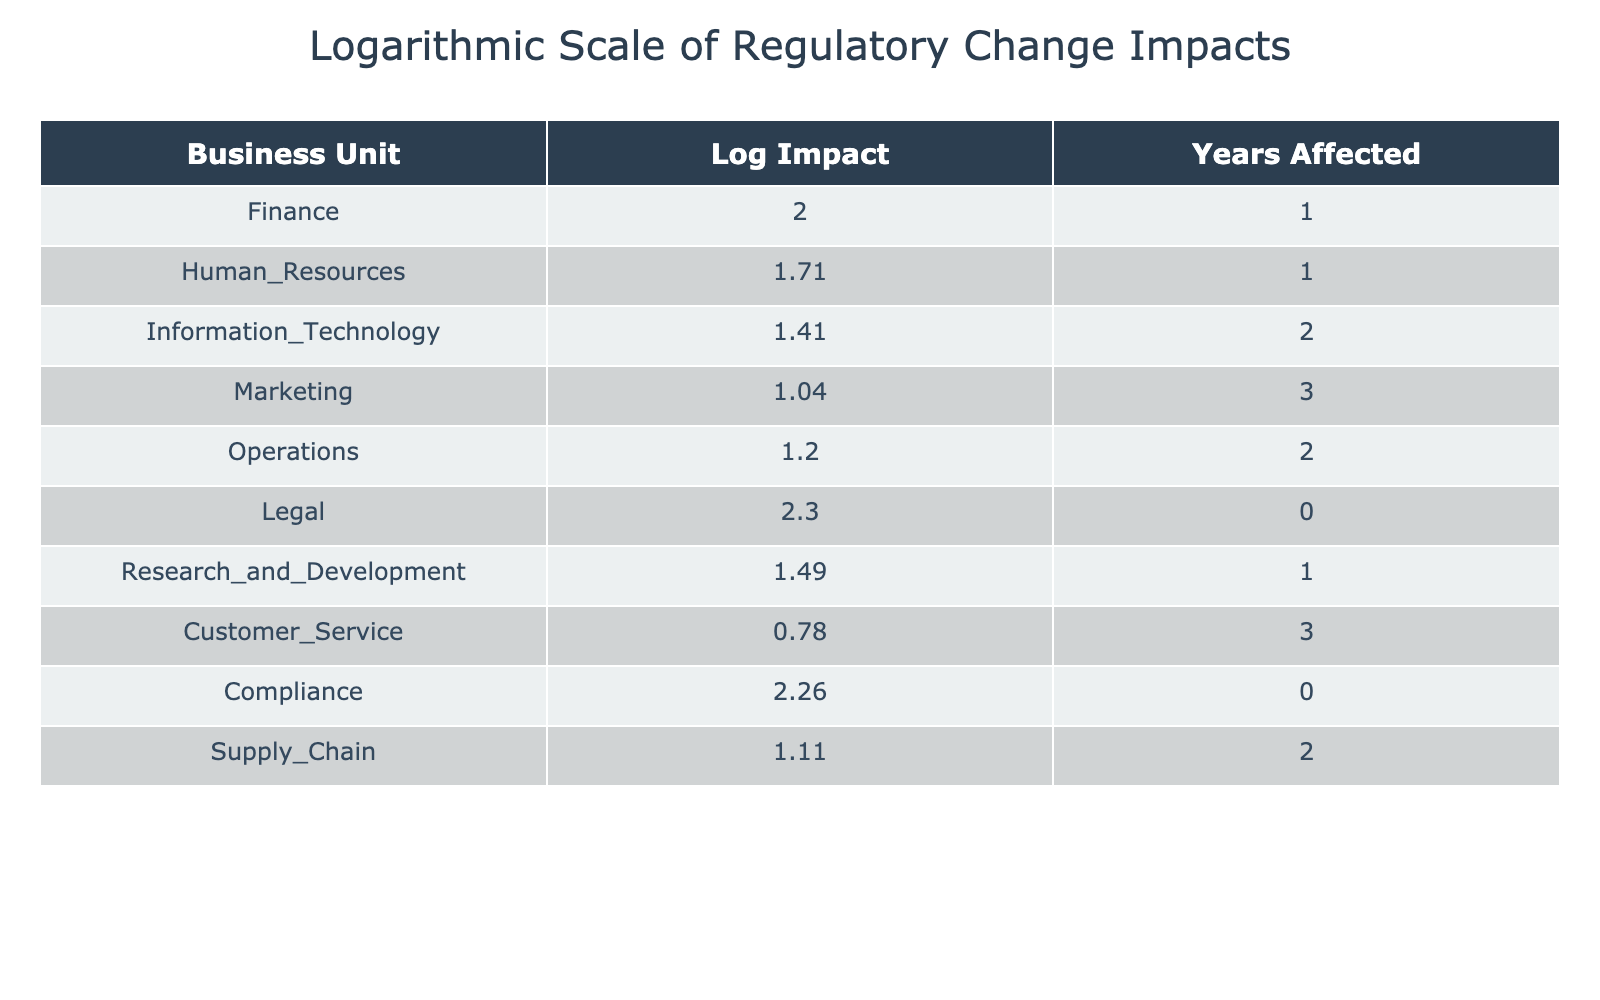What is the Log Impact score for the Finance business unit? The table shows that the Finance business unit has a Regulatory Change Impact Score of 100. The Log Impact for this score can be calculated as log10(100 + 1), which is approximately 2.00. Therefore, the Log Impact score for Finance is 2.00.
Answer: 2.00 Which business unit has the highest Log Impact score? By reviewing the Log Impact scores listed in the table, we observe that the Legal business unit has the highest Regulatory Change Impact Score of 200, which results in a Log Impact score calculated as log10(200 + 1), approximately 2.30. This is higher than any other unit's Log Impact score.
Answer: Legal What is the average Log Impact score of all business units listed? To find the average Log Impact score, we first sum all the individual Log Impact scores from the table and then divide by the number of business units (which is 10). The sum of the Log Impact scores is 2.00 (Finance) + 1.70 (HR) + 1.40 (IT) + 1.00 (Marketing) + 1.10 (Operations) + 2.30 (Legal) + 1.48 (R&D) + 0.70 (Customer Service) + 1.08 (Compliance) + 1.07 (Supply Chain) = 13.65. Dividing that by 10 gives an average of approximately 1.37.
Answer: 1.37 Is there any business unit with a Log Impact score less than 1? Checking the Log Impact scores in the table, we see that Customer Service has a Log Impact score of approximately 0.70. Therefore, there is at least one business unit with a Log Impact score less than 1.
Answer: Yes What is the difference between the Log Impact scores of the Compliance and Information Technology business units? We begin by identifying the Log Impact scores for both units: Compliance has a Log Impact score of approximately 1.26 and Information Technology has a score of approximately 1.40. We calculate the difference by subtracting the Compliance score from the IT score: 1.40 - 1.26 = 0.14.
Answer: 0.14 